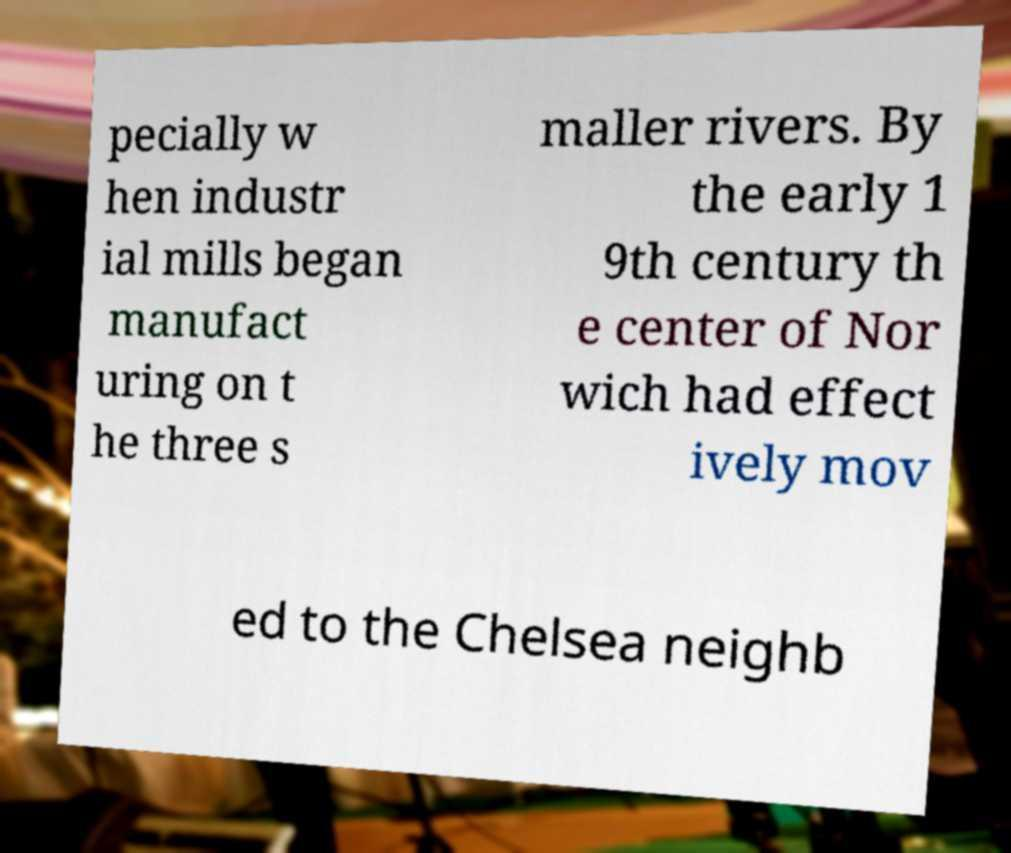There's text embedded in this image that I need extracted. Can you transcribe it verbatim? pecially w hen industr ial mills began manufact uring on t he three s maller rivers. By the early 1 9th century th e center of Nor wich had effect ively mov ed to the Chelsea neighb 